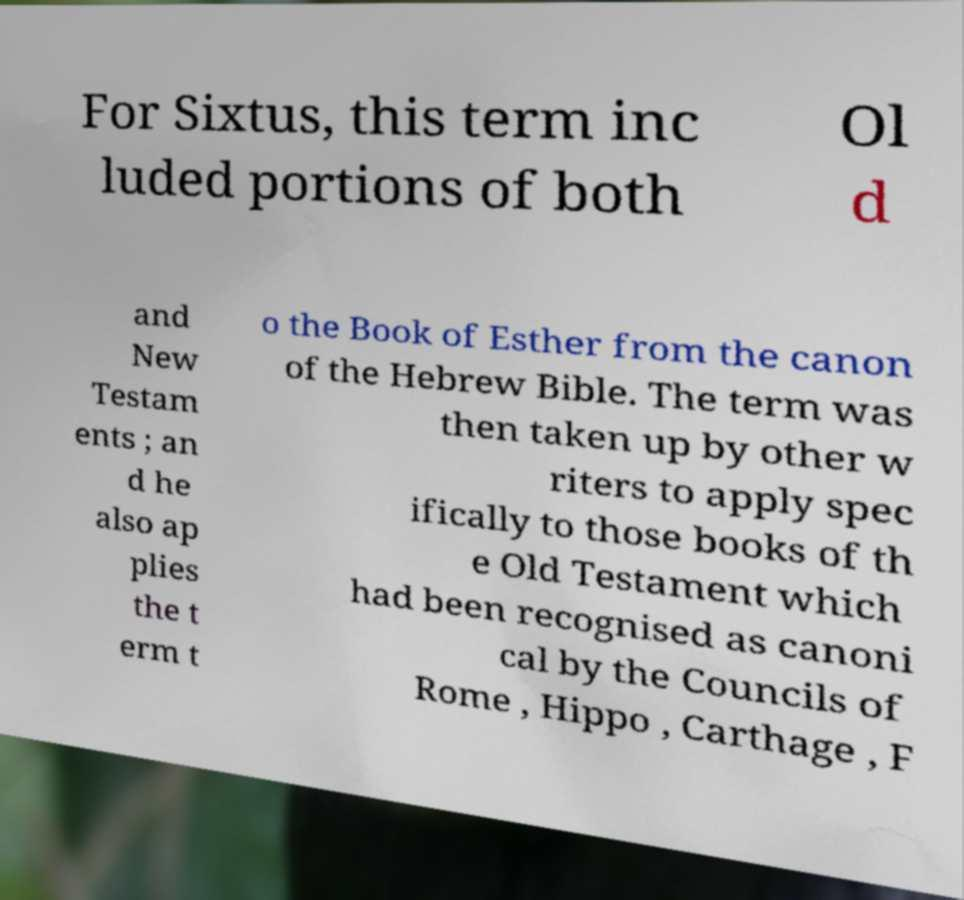Please identify and transcribe the text found in this image. For Sixtus, this term inc luded portions of both Ol d and New Testam ents ; an d he also ap plies the t erm t o the Book of Esther from the canon of the Hebrew Bible. The term was then taken up by other w riters to apply spec ifically to those books of th e Old Testament which had been recognised as canoni cal by the Councils of Rome , Hippo , Carthage , F 